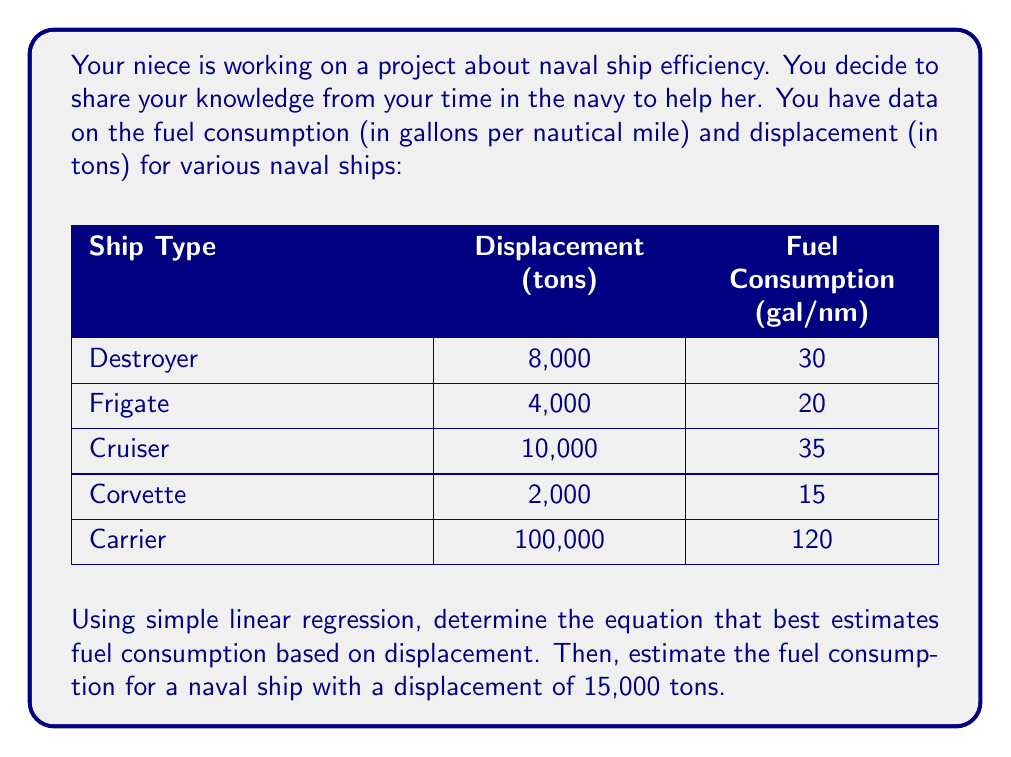What is the answer to this math problem? Let's approach this step-by-step:

1) First, we need to calculate the means of x (displacement) and y (fuel consumption):

   $\bar{x} = \frac{8000 + 4000 + 10000 + 2000 + 100000}{5} = 24800$
   $\bar{y} = \frac{30 + 20 + 35 + 15 + 120}{5} = 44$

2) Now, we calculate the following sums:
   
   $\sum (x - \bar{x})(y - \bar{y})$ and $\sum (x - \bar{x})^2$

   $\sum (x - \bar{x})(y - \bar{y}) = (-16800)(-14) + (-20800)(-24) + (-14800)(-9) + (-22800)(-29) + (75200)(76) = 5,821,600,000$

   $\sum (x - \bar{x})^2 = (-16800)^2 + (-20800)^2 + (-14800)^2 + (-22800)^2 + (75200)^2 = 7,905,760,000$

3) The slope (b) of the regression line is:

   $b = \frac{\sum (x - \bar{x})(y - \bar{y})}{\sum (x - \bar{x})^2} = \frac{5,821,600,000}{7,905,760,000} \approx 0.7364$

4) The y-intercept (a) is:

   $a = \bar{y} - b\bar{x} = 44 - (0.7364 \times 24800) \approx 25.7373$

5) Therefore, the regression equation is:

   $y = 0.7364x + 25.7373$

   Where y is the estimated fuel consumption and x is the displacement.

6) For a ship with 15,000 tons displacement:

   $y = 0.7364(15000) + 25.7373 \approx 136.7$
Answer: The regression equation is $y = 0.7364x + 25.7373$, where y is the estimated fuel consumption in gallons per nautical mile and x is the displacement in tons. For a naval ship with a displacement of 15,000 tons, the estimated fuel consumption is approximately 136.7 gallons per nautical mile. 